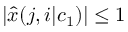<formula> <loc_0><loc_0><loc_500><loc_500>| { \widehat { x } } ( j , i | c _ { 1 } ) | \leq 1</formula> 